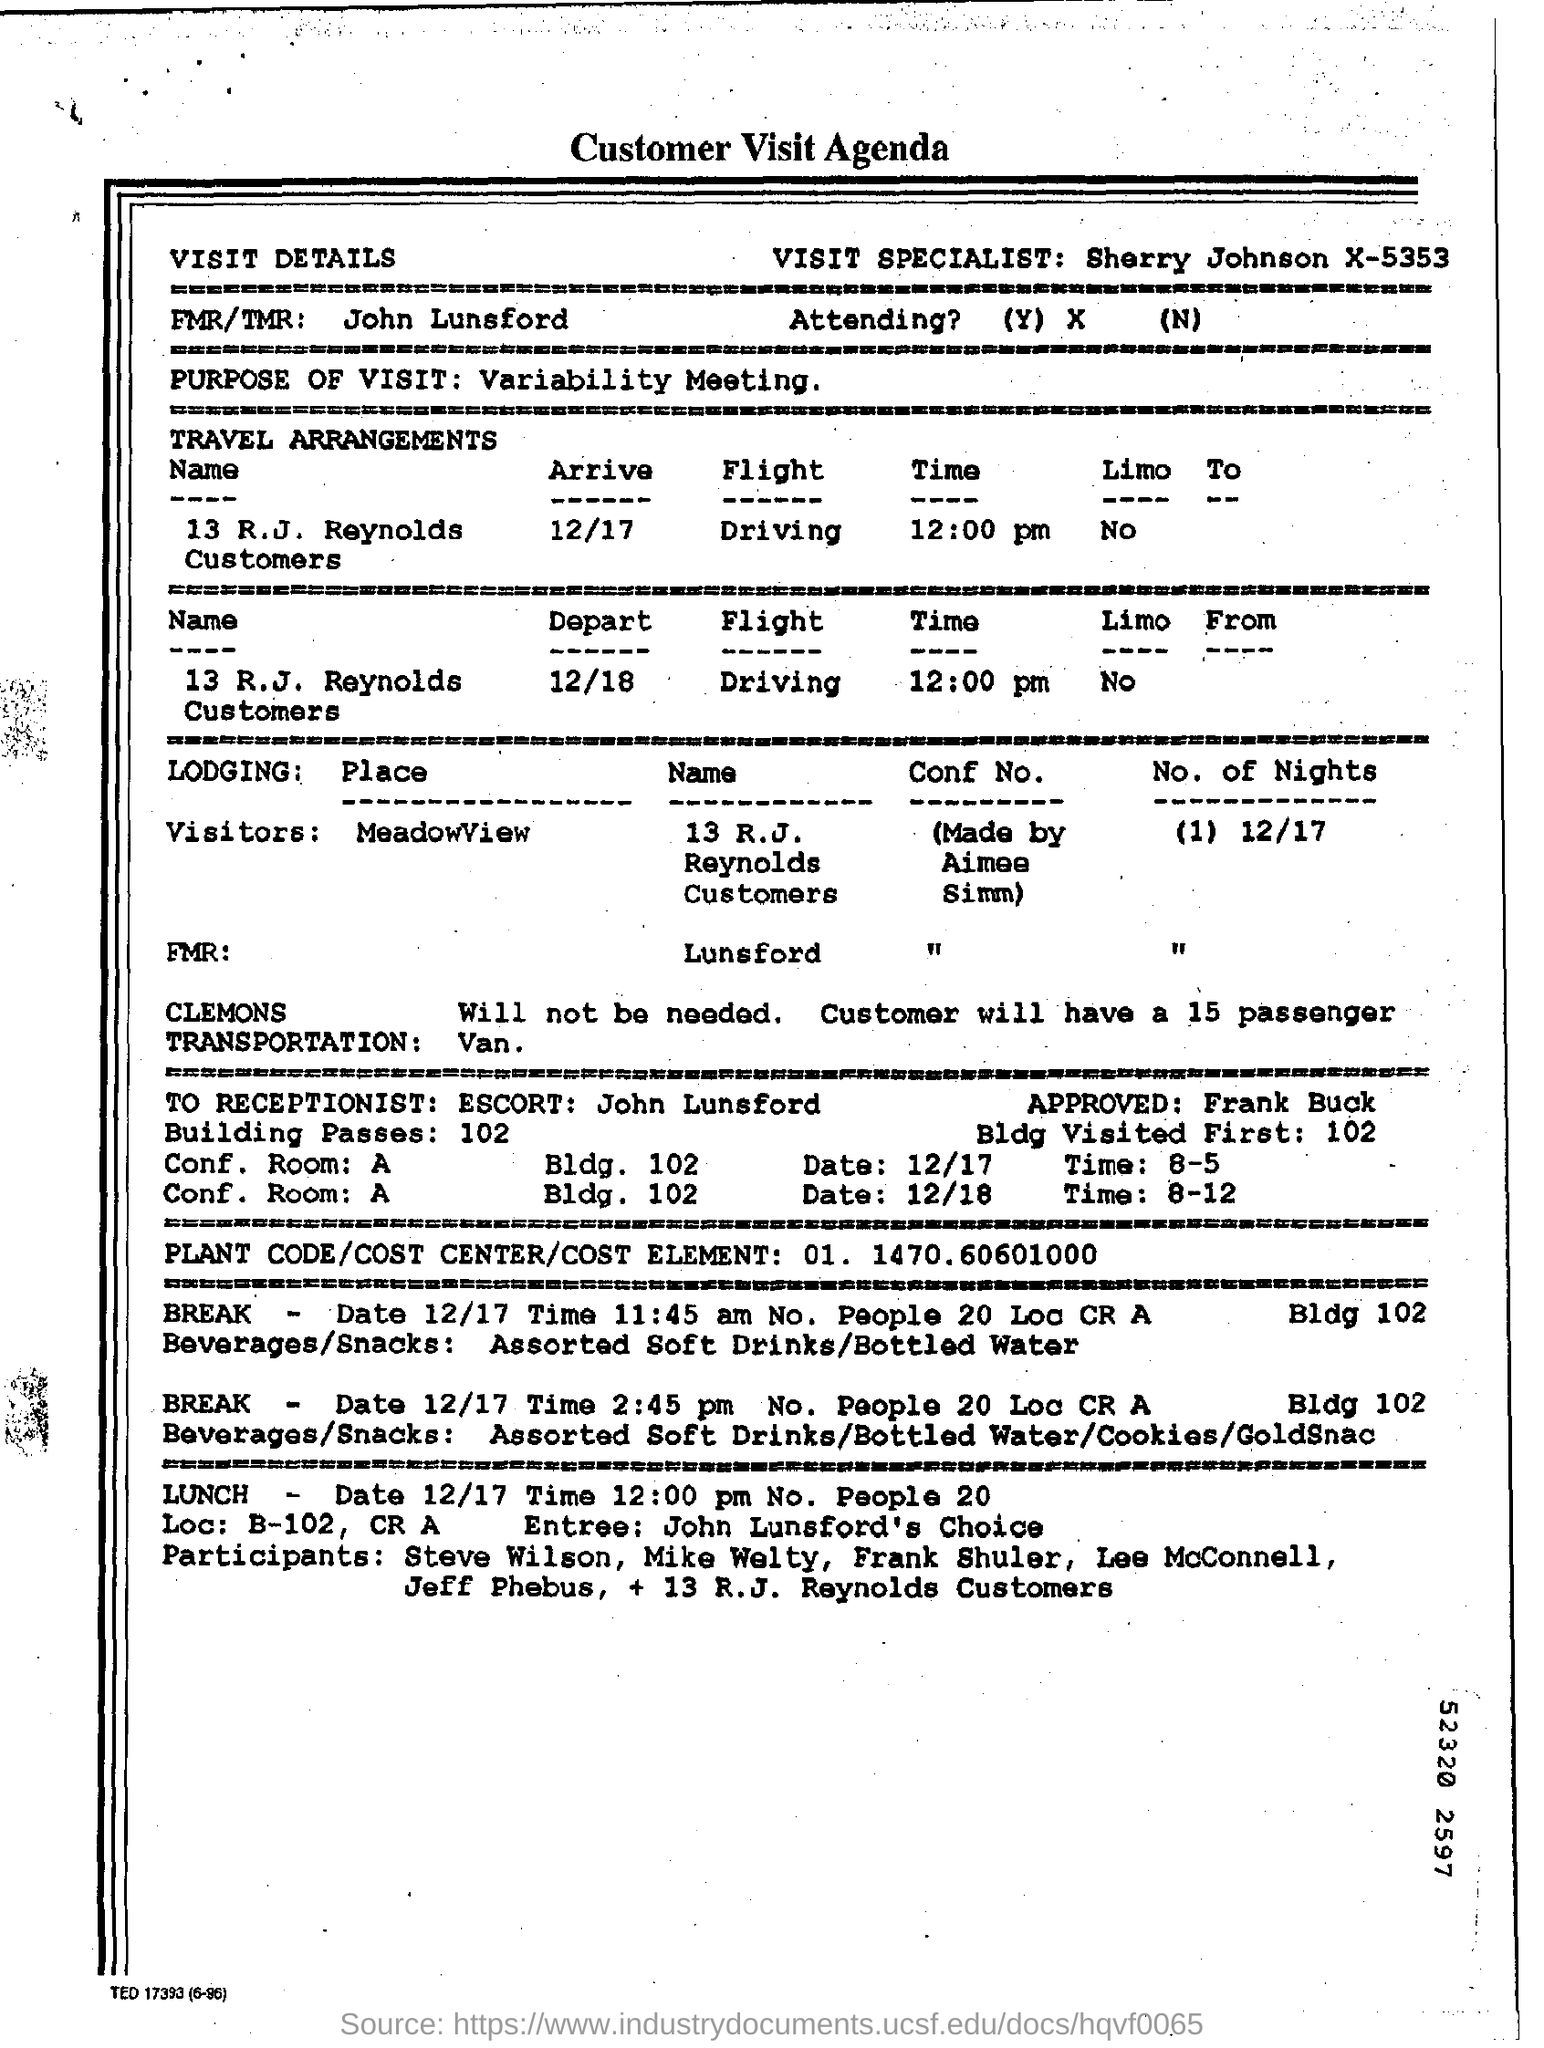Outline some significant characteristics in this image. The Visit Specialist is Sherry Johnson. What is lodging 'place' for visitors?" is a question that is being asked. "MeadowView" is being referred to as the subject of this question. With certainty, John Lunsford is the FMR/TMR. The purpose of the visit is to attend a variability meeting. The number of nights is 1. 